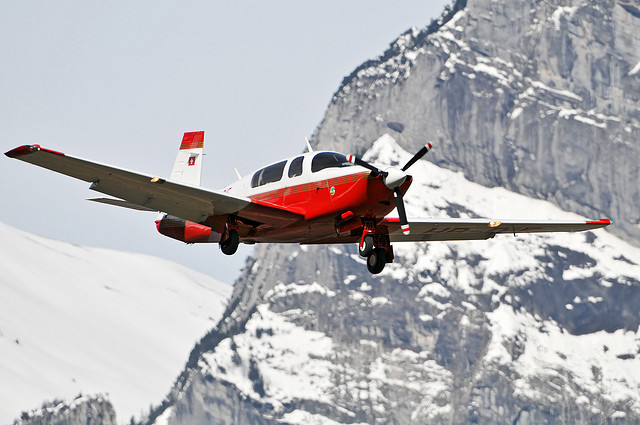<image>What type of plane is this? I don't know what type of plane this is. It could be a small, propeller, single propeller, or a small personal plane. What type of plane is this? I am not sure what type of plane this is. It can be seen as a small propeller plane, a propeller plane, a private plane, a single propeller plane, or a biplane. 